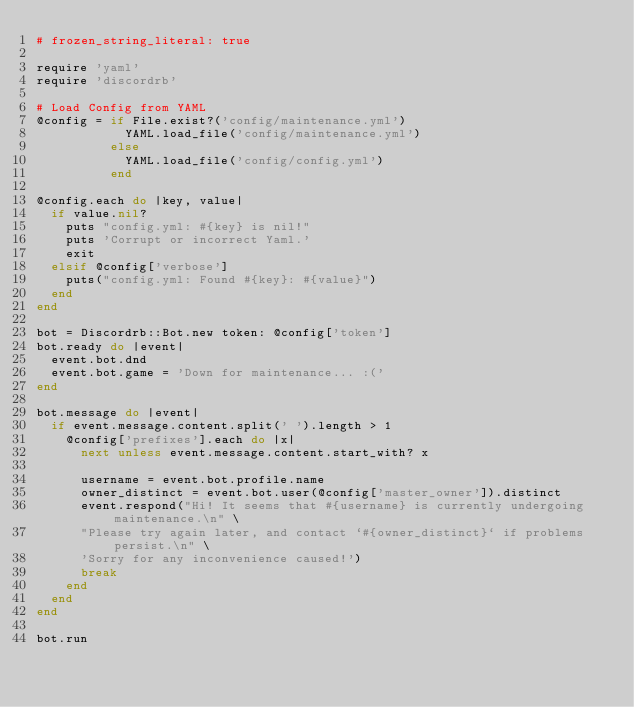Convert code to text. <code><loc_0><loc_0><loc_500><loc_500><_Ruby_># frozen_string_literal: true

require 'yaml'
require 'discordrb'

# Load Config from YAML
@config = if File.exist?('config/maintenance.yml')
            YAML.load_file('config/maintenance.yml')
          else
            YAML.load_file('config/config.yml')
          end

@config.each do |key, value|
  if value.nil?
    puts "config.yml: #{key} is nil!"
    puts 'Corrupt or incorrect Yaml.'
    exit
  elsif @config['verbose']
    puts("config.yml: Found #{key}: #{value}")
  end
end

bot = Discordrb::Bot.new token: @config['token']
bot.ready do |event|
  event.bot.dnd
  event.bot.game = 'Down for maintenance... :('
end

bot.message do |event|
  if event.message.content.split(' ').length > 1
    @config['prefixes'].each do |x|
      next unless event.message.content.start_with? x

      username = event.bot.profile.name
      owner_distinct = event.bot.user(@config['master_owner']).distinct
      event.respond("Hi! It seems that #{username} is currently undergoing maintenance.\n" \
      "Please try again later, and contact `#{owner_distinct}` if problems persist.\n" \
      'Sorry for any inconvenience caused!')
      break
    end
  end
end

bot.run
</code> 